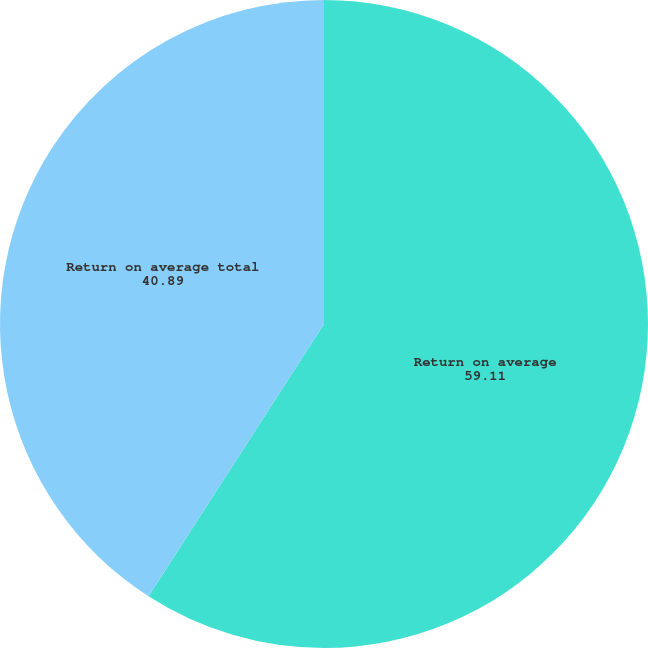Convert chart. <chart><loc_0><loc_0><loc_500><loc_500><pie_chart><fcel>Return on average<fcel>Return on average total<nl><fcel>59.11%<fcel>40.89%<nl></chart> 